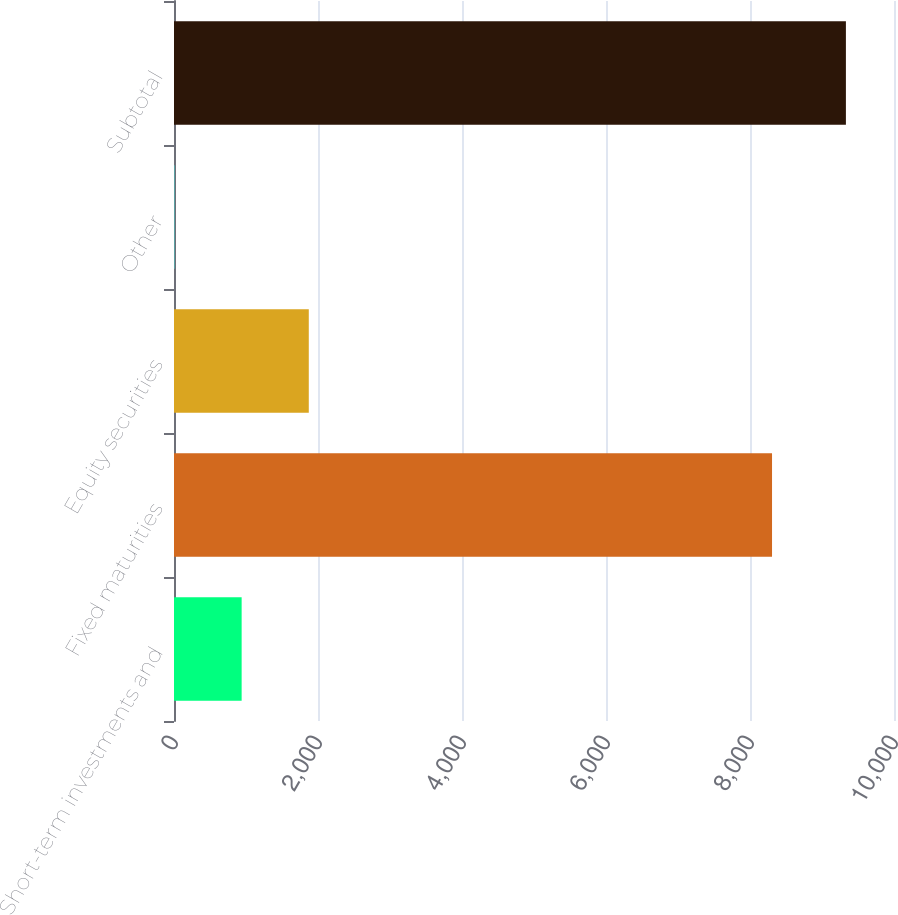<chart> <loc_0><loc_0><loc_500><loc_500><bar_chart><fcel>Short-term investments and<fcel>Fixed maturities<fcel>Equity securities<fcel>Other<fcel>Subtotal<nl><fcel>939.5<fcel>8306<fcel>1872<fcel>7<fcel>9332<nl></chart> 